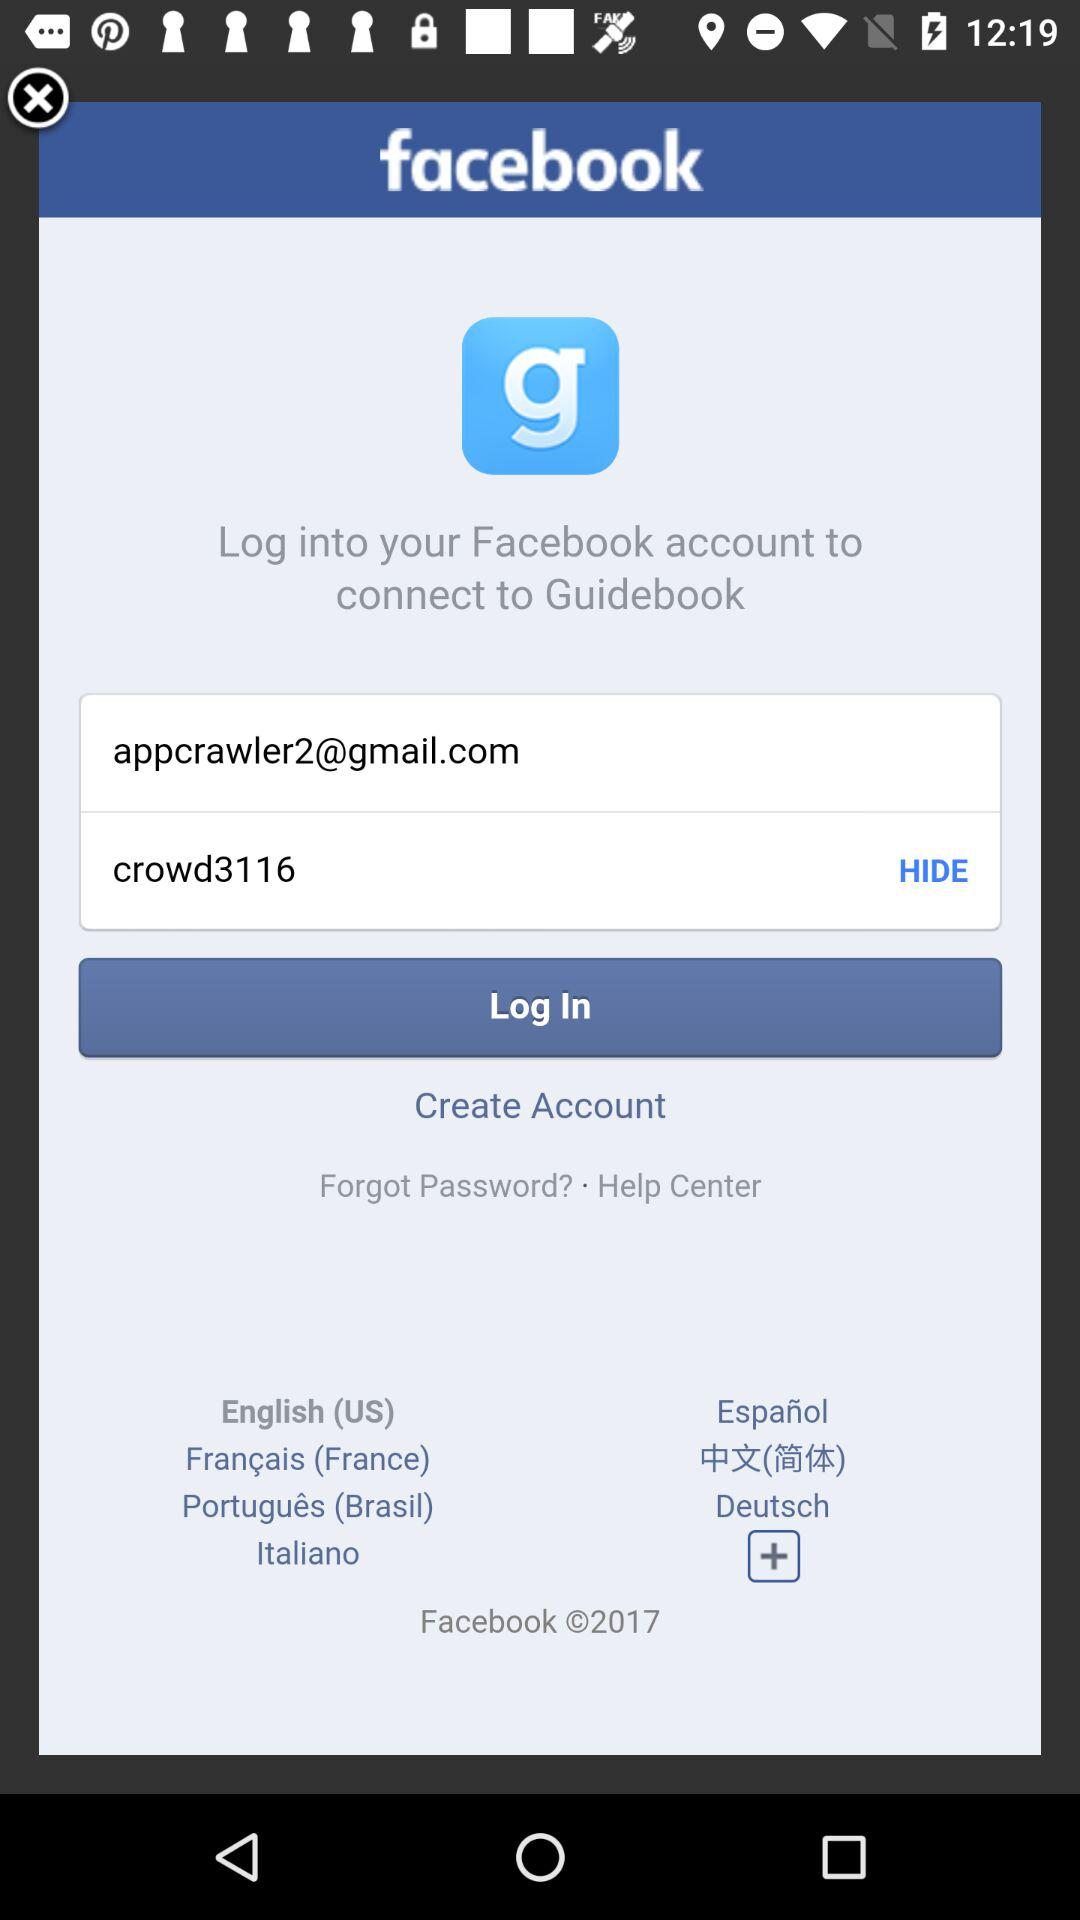Which application is asking for logging in? The application that is asking for logging in is "Guidebook". 